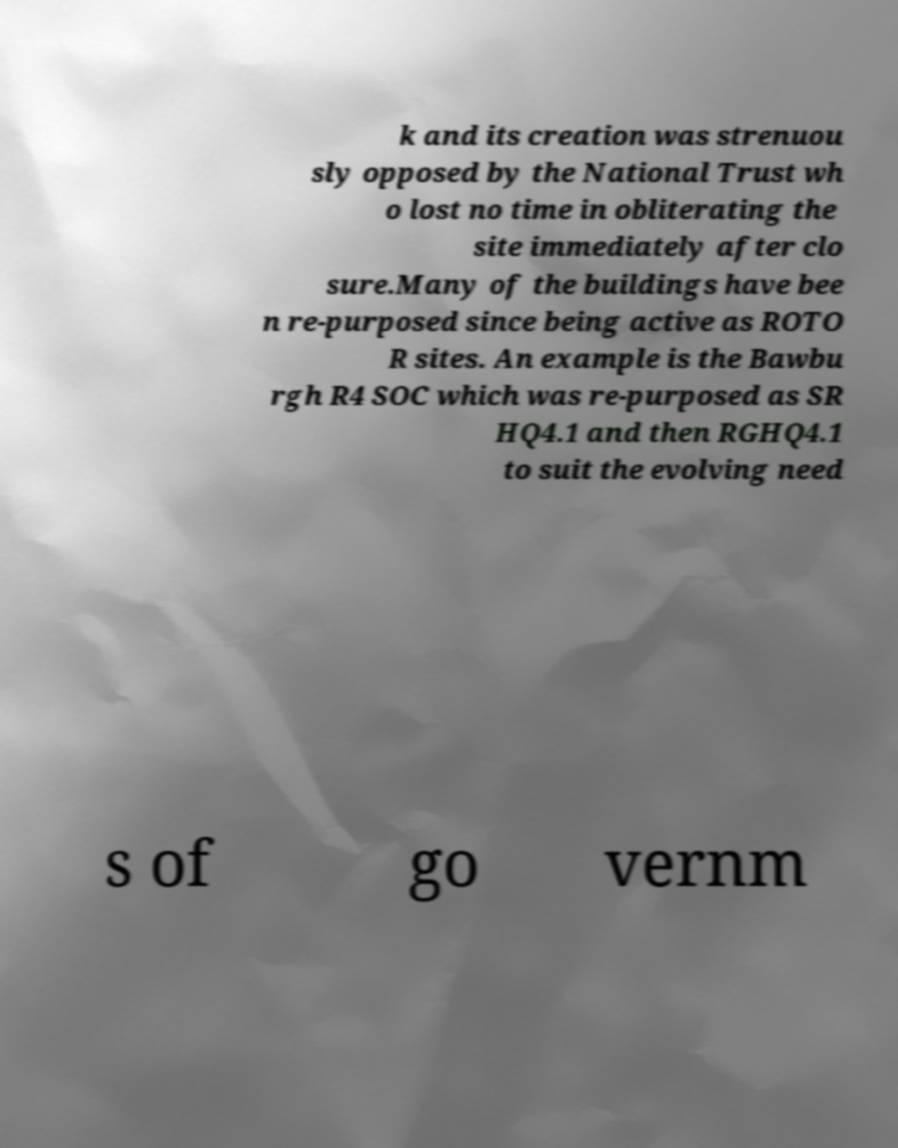Could you extract and type out the text from this image? k and its creation was strenuou sly opposed by the National Trust wh o lost no time in obliterating the site immediately after clo sure.Many of the buildings have bee n re-purposed since being active as ROTO R sites. An example is the Bawbu rgh R4 SOC which was re-purposed as SR HQ4.1 and then RGHQ4.1 to suit the evolving need s of go vernm 